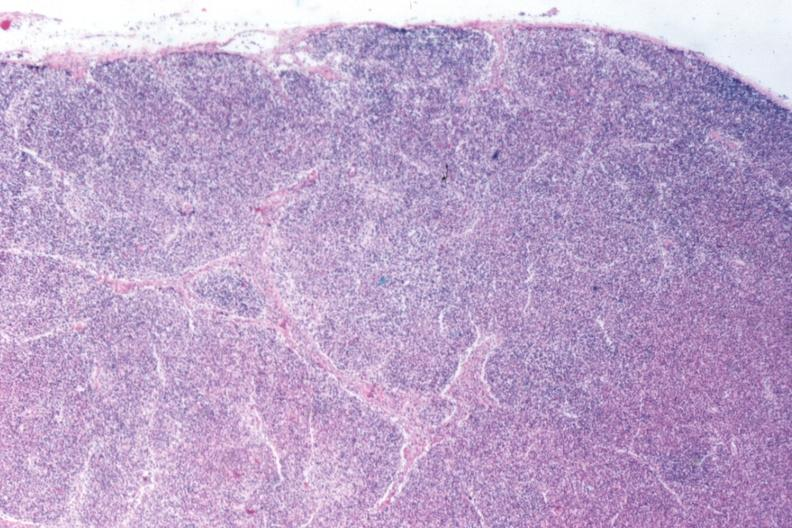what is present?
Answer the question using a single word or phrase. Chronic myelogenous leukemia 